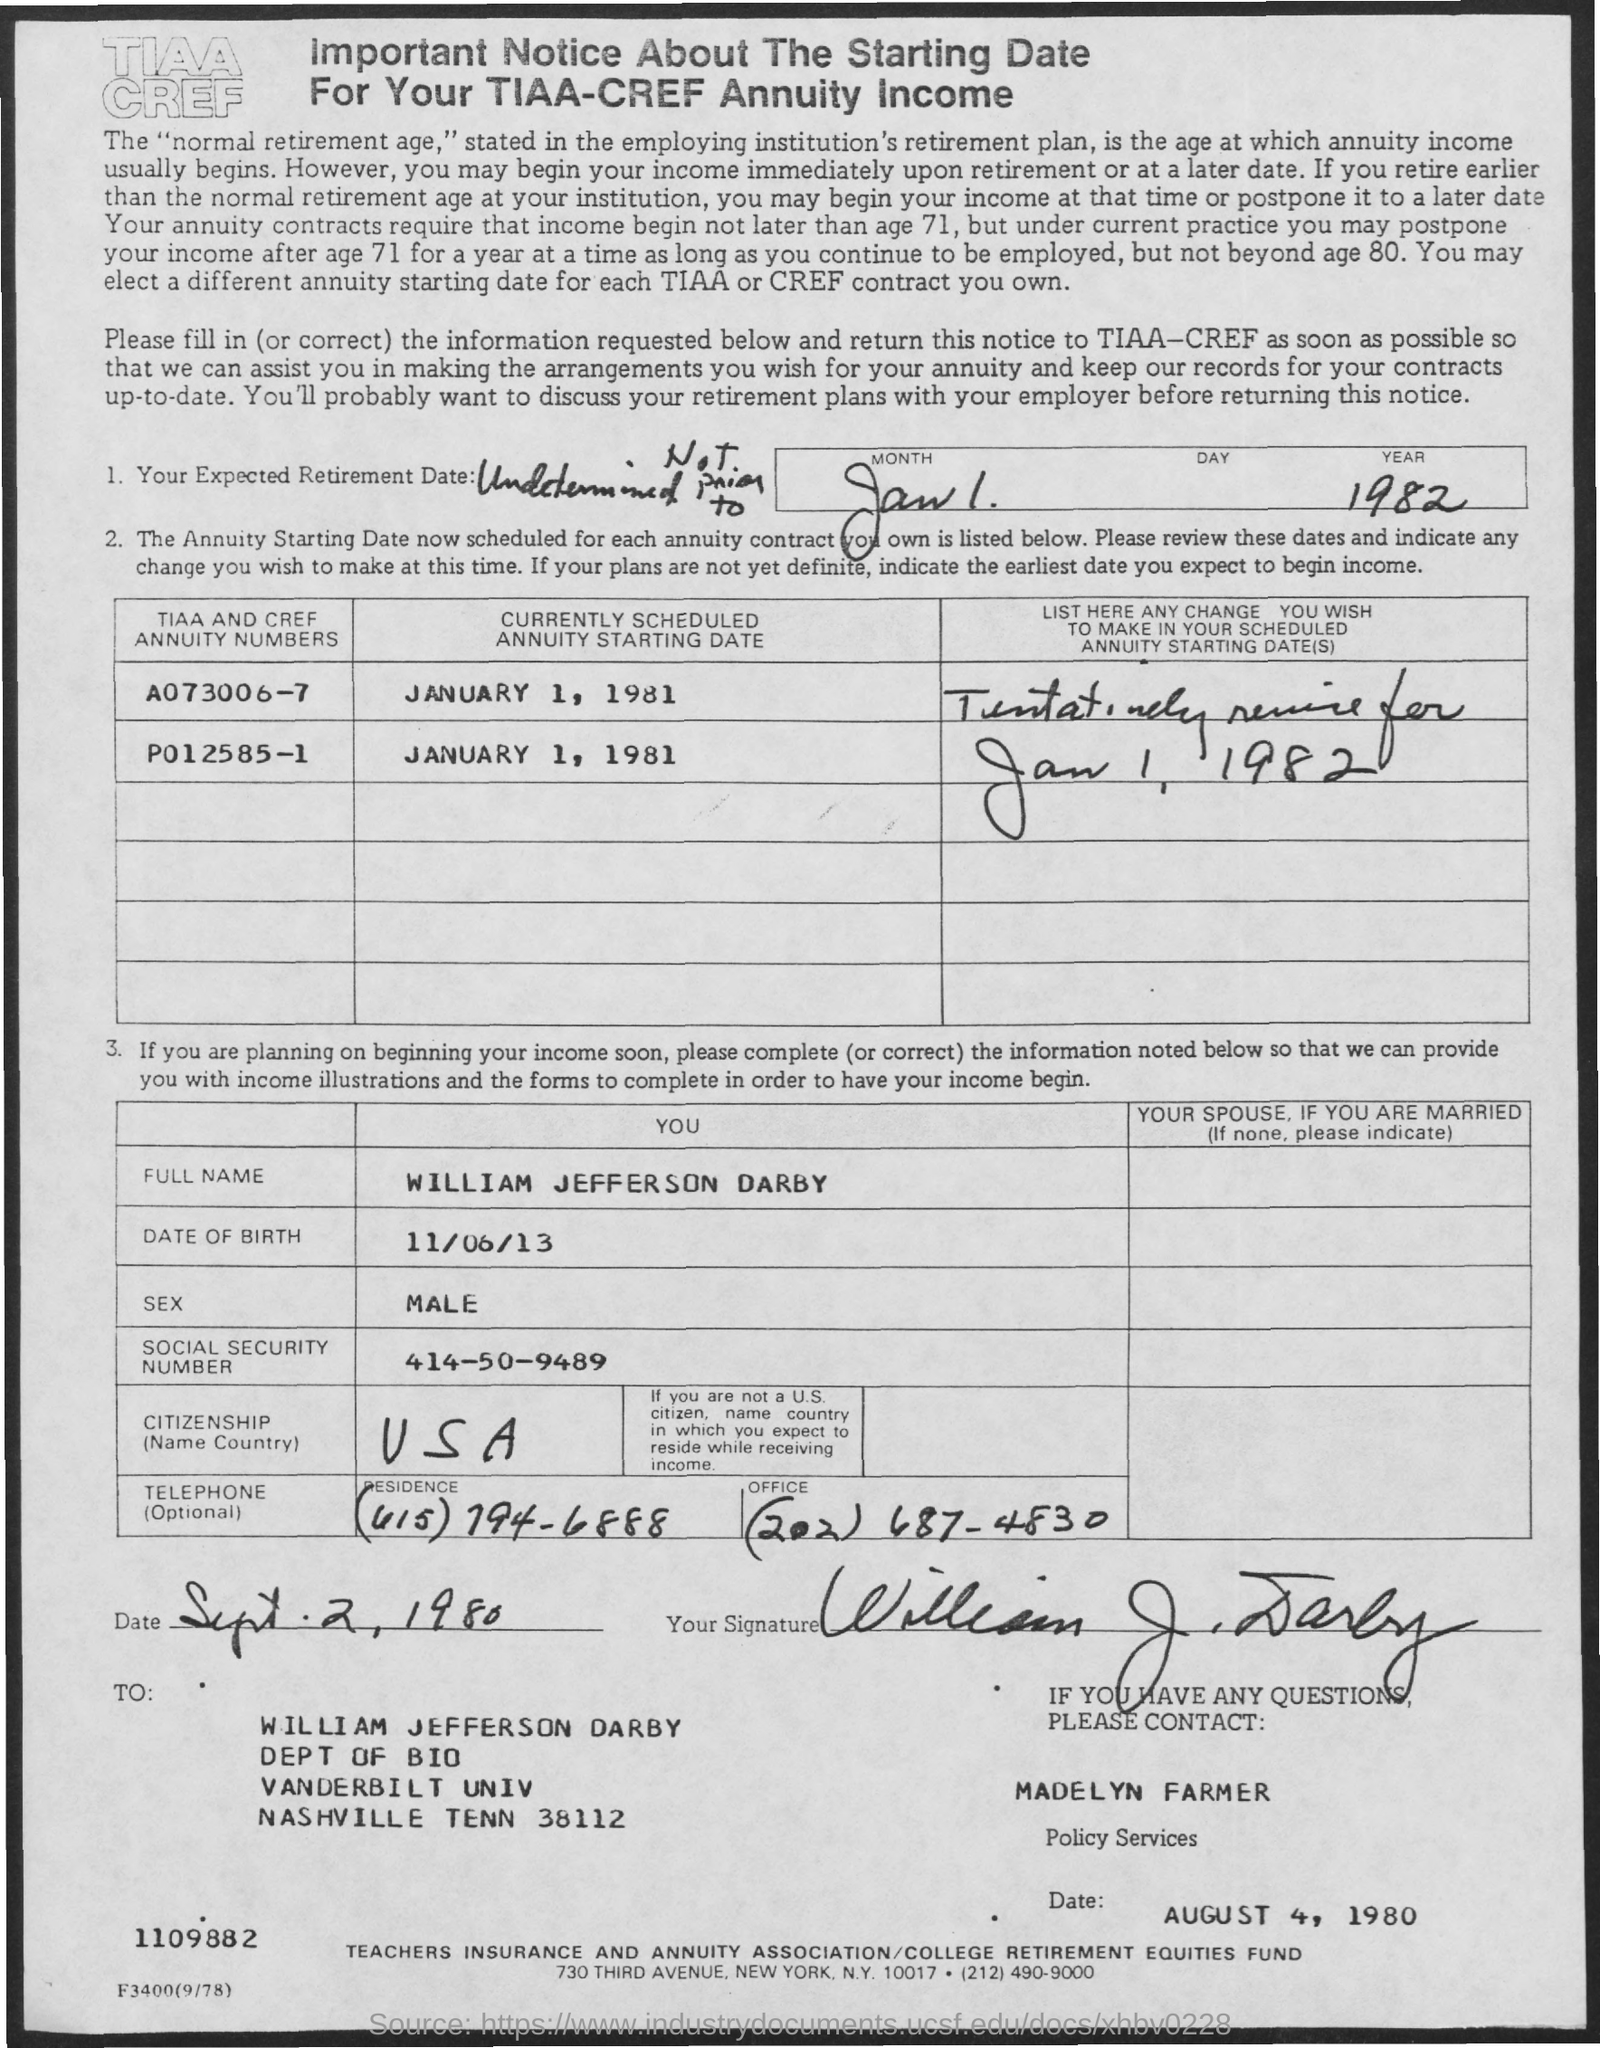Identify some key points in this picture. It is important to note that the starting date for your TIAA-CREF annuity income has been established. The person to contact for questions is Madelyn Farmer. The office telephone number is (202) 687-4830. The full name given is William Jefferson Darby. The currently scheduled annuity starting date of A073006-7 is January 1, 1981. 